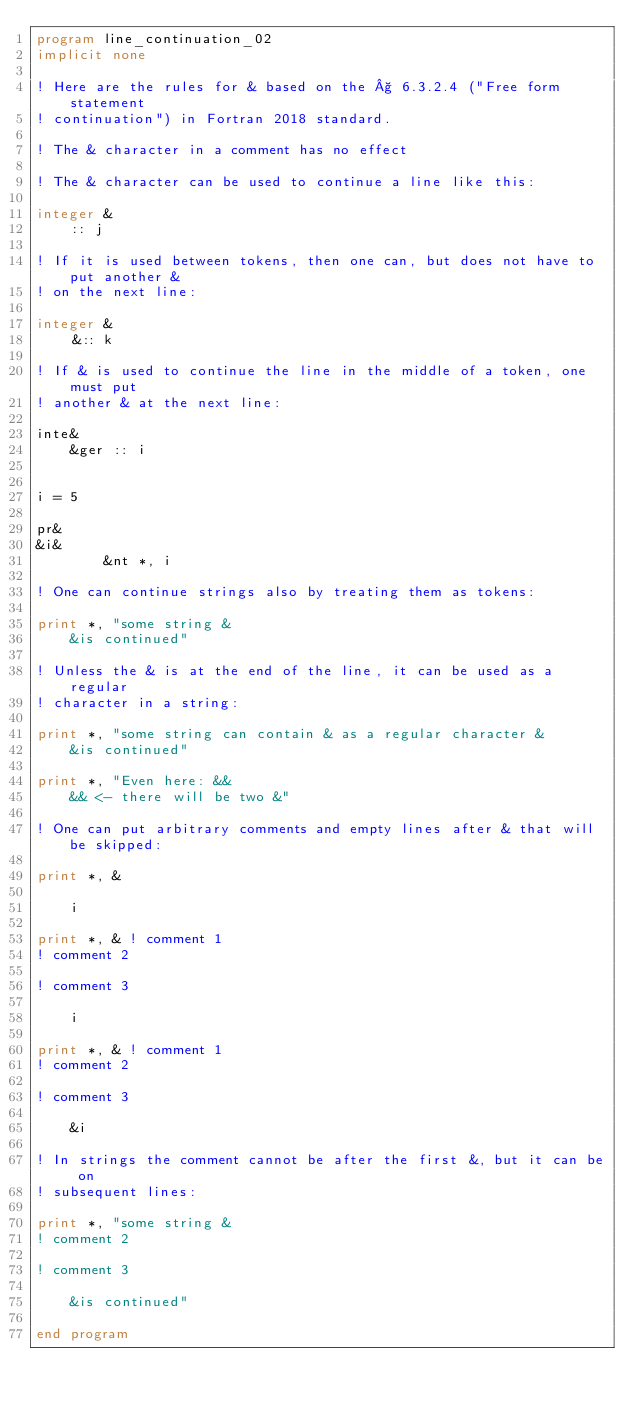Convert code to text. <code><loc_0><loc_0><loc_500><loc_500><_FORTRAN_>program line_continuation_02
implicit none

! Here are the rules for & based on the § 6.3.2.4 ("Free form statement
! continuation") in Fortran 2018 standard.

! The & character in a comment has no effect

! The & character can be used to continue a line like this:

integer &
    :: j

! If it is used between tokens, then one can, but does not have to put another &
! on the next line:

integer &
    &:: k

! If & is used to continue the line in the middle of a token, one must put
! another & at the next line:

inte&
    &ger :: i


i = 5

pr&
&i&
        &nt *, i

! One can continue strings also by treating them as tokens:

print *, "some string &
    &is continued"

! Unless the & is at the end of the line, it can be used as a regular
! character in a string:

print *, "some string can contain & as a regular character &
    &is continued"

print *, "Even here: &&
    && <- there will be two &"

! One can put arbitrary comments and empty lines after & that will be skipped:

print *, &

    i

print *, & ! comment 1
! comment 2

! comment 3

    i

print *, & ! comment 1
! comment 2

! comment 3

    &i

! In strings the comment cannot be after the first &, but it can be on
! subsequent lines:

print *, "some string &
! comment 2

! comment 3

    &is continued"

end program
</code> 